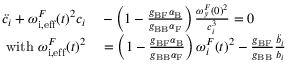<formula> <loc_0><loc_0><loc_500><loc_500>\begin{array} { r l } { \ddot { c } _ { i } + { { \omega _ { i , e f f } ^ { F } } } ( t ) ^ { 2 } c _ { i } } & - \left ( 1 - \frac { g _ { B F } \alpha _ { B } } { g _ { B B } \alpha _ { F } } \right ) \frac { { \omega _ { y } ^ { F } } ( 0 ) ^ { 2 } } { c _ { i } ^ { 3 } } = 0 } \\ { { w i t h { \omega _ { i , e f f } ^ { F } } } ( t ) ^ { 2 } } & = \left ( 1 - \frac { g _ { B F } \alpha _ { B } } { g _ { B B } \alpha _ { F } } \right ) { \omega _ { i } ^ { F } } ( t ) ^ { 2 } - \frac { g _ { B F } } { g _ { B B } } \frac { \ddot { b _ { i } } } { b _ { i } } } \end{array}</formula> 